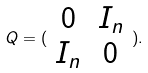Convert formula to latex. <formula><loc_0><loc_0><loc_500><loc_500>Q = ( \begin{array} { c c } 0 & I _ { n } \\ I _ { n } & 0 \end{array} ) .</formula> 